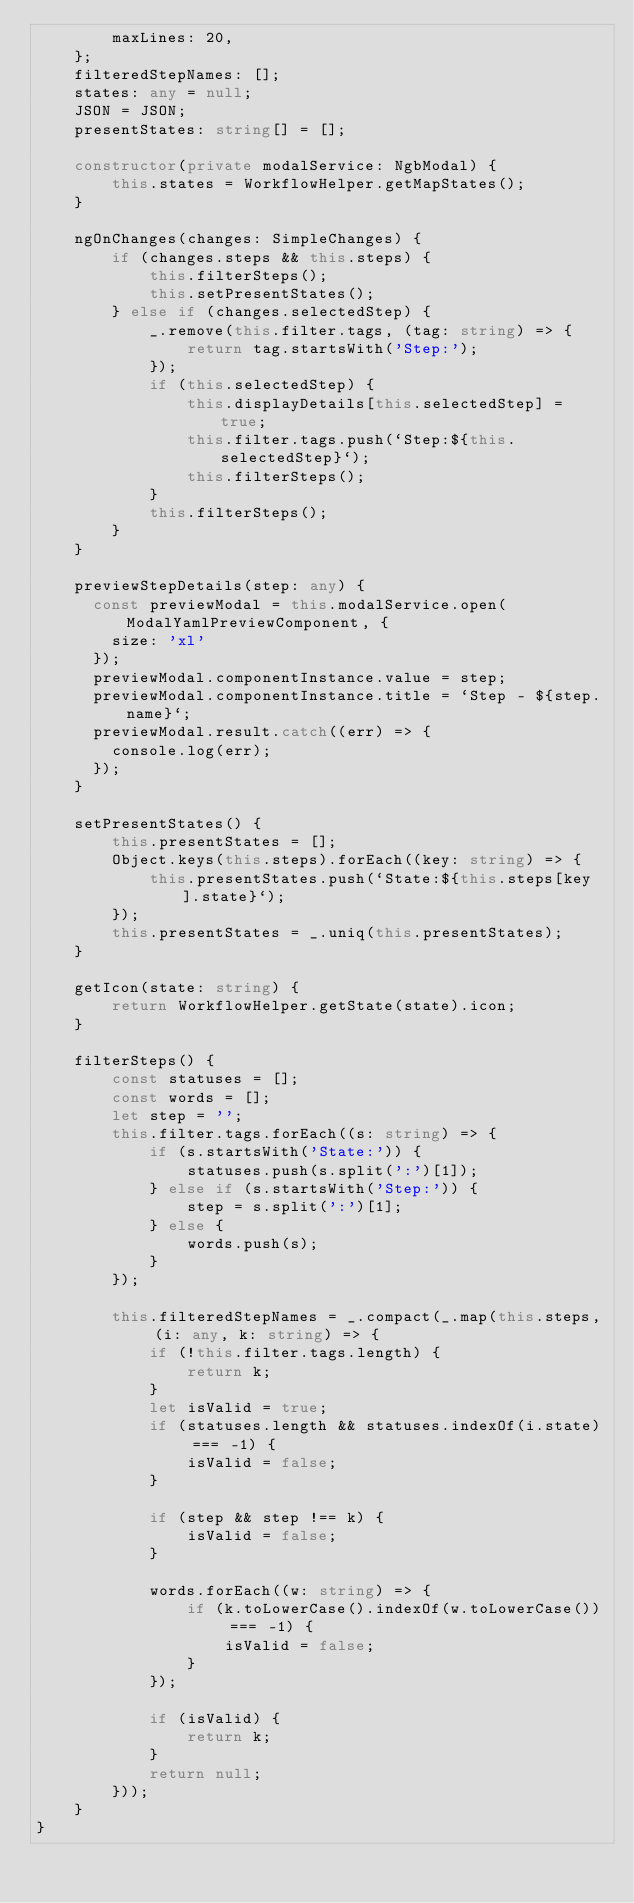<code> <loc_0><loc_0><loc_500><loc_500><_TypeScript_>        maxLines: 20,
    };
    filteredStepNames: [];
    states: any = null;
    JSON = JSON;
    presentStates: string[] = [];

    constructor(private modalService: NgbModal) {
        this.states = WorkflowHelper.getMapStates();
    }

    ngOnChanges(changes: SimpleChanges) {
        if (changes.steps && this.steps) {
            this.filterSteps();
            this.setPresentStates();
        } else if (changes.selectedStep) {
            _.remove(this.filter.tags, (tag: string) => {
                return tag.startsWith('Step:');
            });
            if (this.selectedStep) {
                this.displayDetails[this.selectedStep] = true;
                this.filter.tags.push(`Step:${this.selectedStep}`);
                this.filterSteps();
            }
            this.filterSteps();
        }
    }

    previewStepDetails(step: any) {
      const previewModal = this.modalService.open(ModalYamlPreviewComponent, {
        size: 'xl'
      });
      previewModal.componentInstance.value = step;
      previewModal.componentInstance.title = `Step - ${step.name}`;
      previewModal.result.catch((err) => {
        console.log(err);
      });
    }

    setPresentStates() {
        this.presentStates = [];
        Object.keys(this.steps).forEach((key: string) => {
            this.presentStates.push(`State:${this.steps[key].state}`);
        });
        this.presentStates = _.uniq(this.presentStates);
    }

    getIcon(state: string) {
        return WorkflowHelper.getState(state).icon;
    }

    filterSteps() {
        const statuses = [];
        const words = [];
        let step = '';
        this.filter.tags.forEach((s: string) => {
            if (s.startsWith('State:')) {
                statuses.push(s.split(':')[1]);
            } else if (s.startsWith('Step:')) {
                step = s.split(':')[1];
            } else {
                words.push(s);
            }
        });

        this.filteredStepNames = _.compact(_.map(this.steps, (i: any, k: string) => {
            if (!this.filter.tags.length) {
                return k;
            }
            let isValid = true;
            if (statuses.length && statuses.indexOf(i.state) === -1) {
                isValid = false;
            }

            if (step && step !== k) {
                isValid = false;
            }

            words.forEach((w: string) => {
                if (k.toLowerCase().indexOf(w.toLowerCase()) === -1) {
                    isValid = false;
                }
            });

            if (isValid) {
                return k;
            }
            return null;
        }));
    }
}
</code> 